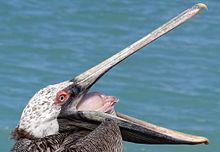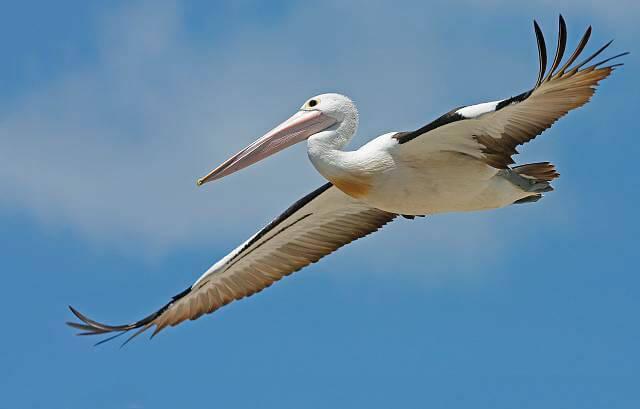The first image is the image on the left, the second image is the image on the right. Considering the images on both sides, is "The bird in the image on the left is flying." valid? Answer yes or no. No. The first image is the image on the left, the second image is the image on the right. Considering the images on both sides, is "There are more pelican birds in the right image than in the left." valid? Answer yes or no. No. 